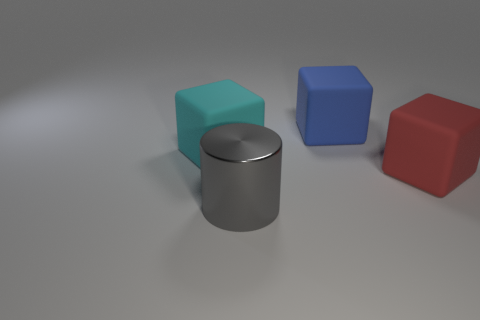Are there any other things that have the same material as the gray cylinder?
Give a very brief answer. No. The blue cube that is the same material as the red object is what size?
Your response must be concise. Large. How big is the gray metal cylinder?
Your answer should be very brief. Large. What shape is the large cyan matte thing?
Your answer should be compact. Cube. There is a big block in front of the big cyan matte object; is its color the same as the metallic cylinder?
Your response must be concise. No. What is the size of the blue matte thing that is the same shape as the red thing?
Offer a very short reply. Large. There is a object that is in front of the rubber thing in front of the cyan rubber thing; are there any large metallic things that are in front of it?
Provide a short and direct response. No. There is a big object right of the blue rubber cube; what is its material?
Ensure brevity in your answer.  Rubber. How many large objects are either cyan matte blocks or metal cylinders?
Provide a succinct answer. 2. There is a cube that is on the left side of the blue object; is it the same size as the shiny cylinder?
Give a very brief answer. Yes. 